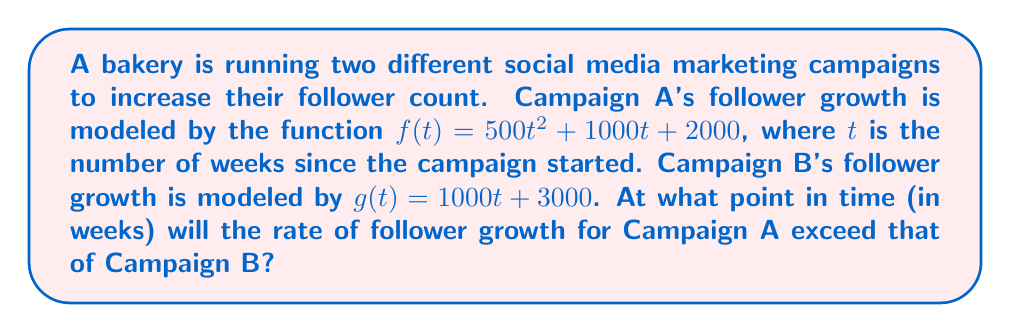Give your solution to this math problem. To solve this problem, we need to follow these steps:

1) First, we need to find the rate of follower growth for each campaign. This is done by taking the derivative of each function with respect to time (t).

   For Campaign A: $f'(t) = \frac{d}{dt}(500t^2 + 1000t + 2000) = 1000t + 1000$
   For Campaign B: $g'(t) = \frac{d}{dt}(1000t + 3000) = 1000$

2) We want to find when $f'(t) > g'(t)$. So, we set up the inequality:

   $1000t + 1000 > 1000$

3) Solve the inequality:

   $1000t > 0$
   $t > 0$

4) Since $t$ represents time, which can't be negative, and we're looking for the point when Campaign A's growth rate exceeds Campaign B's, we need the smallest positive value of $t$ that satisfies this inequality.

5) In this case, any positive value of $t$ will satisfy the inequality. The growth rate of Campaign A will exceed that of Campaign B immediately after the campaign starts (i.e., as soon as $t$ becomes positive).

Therefore, Campaign A's follower growth rate will exceed Campaign B's growth rate immediately after the start of the campaigns.
Answer: $t > 0$ weeks 